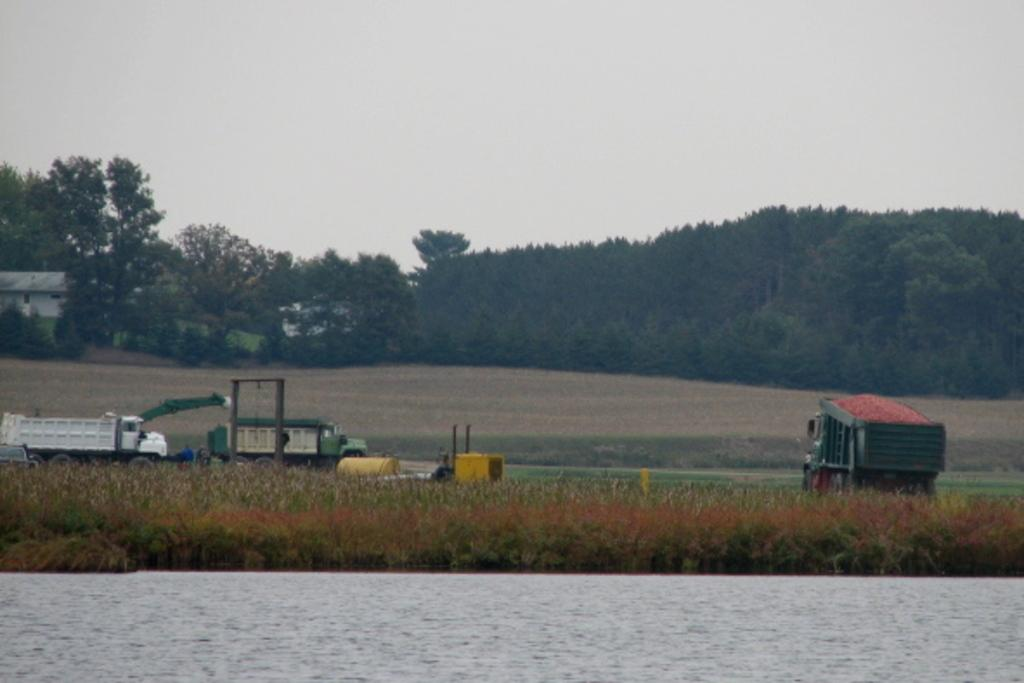What is one of the natural elements visible in the image? Water is visible in the image. What type of vegetation can be seen in the image? There is grass in the image. What type of man-made objects are present in the image? Vehicles are present in the image. What can be seen in the background of the image? There are trees and the sky visible in the background of the image. What type of punishment is being administered to the trees in the image? There is no punishment being administered to the trees in the image; they are simply visible in the background. 